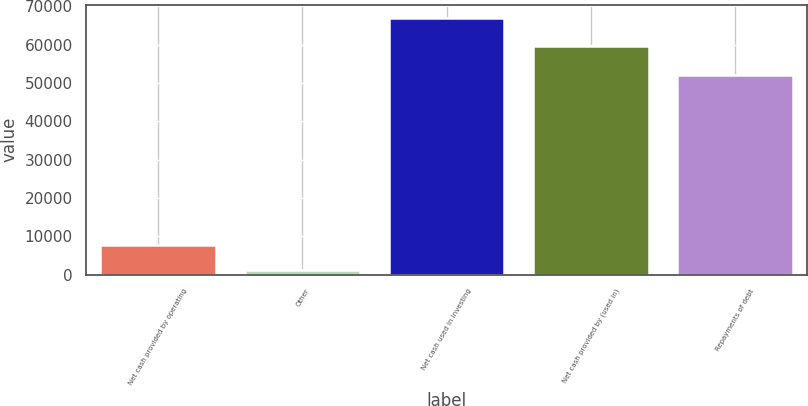<chart> <loc_0><loc_0><loc_500><loc_500><bar_chart><fcel>Net cash provided by operating<fcel>Other<fcel>Net cash used in investing<fcel>Net cash provided by (used in)<fcel>Repayments of debt<nl><fcel>7691.3<fcel>1097<fcel>67040<fcel>59790<fcel>52104<nl></chart> 